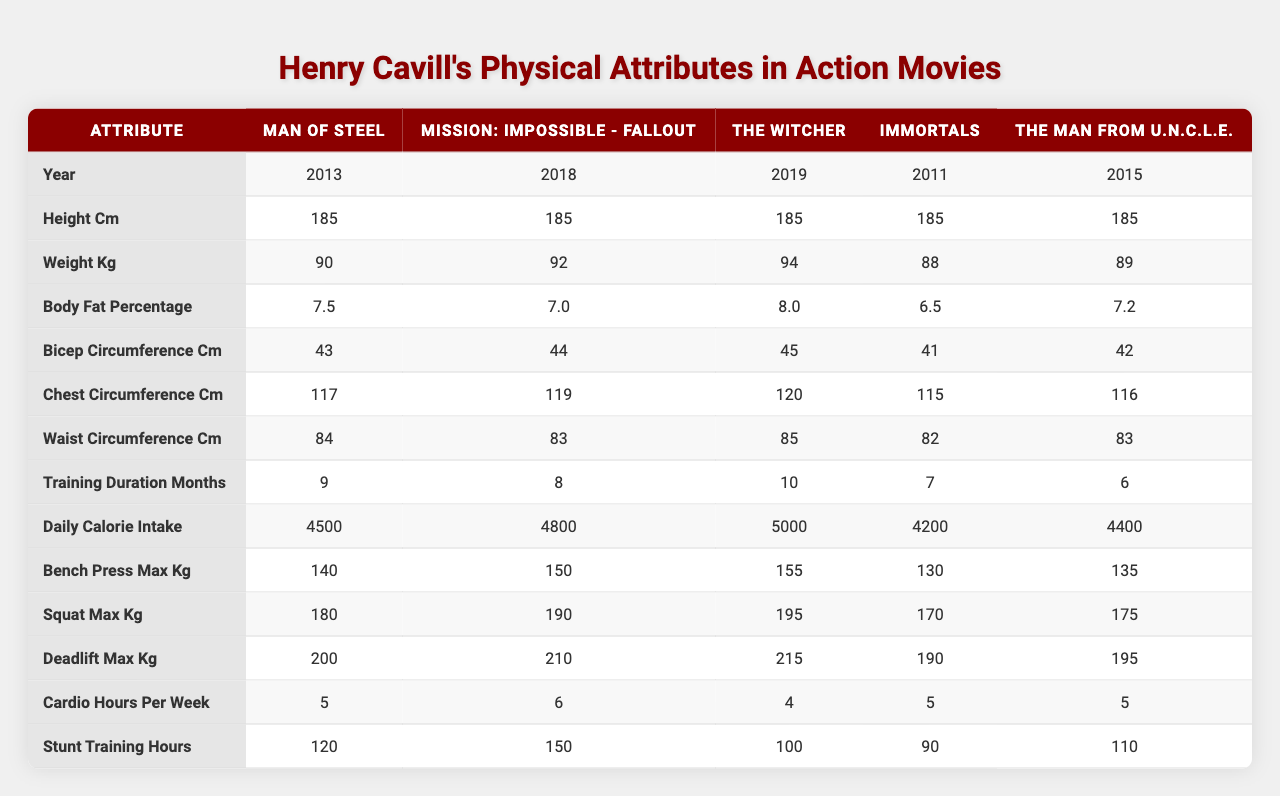What is the height of Henry Cavill in all these movies? The height is consistent across all listed movies, as seen in the table where each entry shows a height of 185 cm.
Answer: 185 cm What is the weight of Henry Cavill in "Man of Steel"? Referring to the entry for "Man of Steel" in the weight column, it shows 90 kg.
Answer: 90 kg Which movie had the highest body fat percentage for Henry Cavill? By comparing the body fat percentages across the movies listed, "The Witcher" has the highest percentage at 8.0%.
Answer: The Witcher Calculate the average weight of Henry Cavill across all movies listed. Adding the weights: 90 + 92 + 94 + 88 + 89 = 453 kg. There are 5 movies, so dividing 453 by 5 gives an average of 90.6 kg.
Answer: 90.6 kg True or False: Henry Cavill's maximum deadlift weight was the same in "Immortals" and "The Man from U.N.C.L.E." The table shows the deadlift maximum for "Immortals" is 190 kg and for "The Man from U.N.C.L.E." it is 195 kg. Since these are not equal, the statement is false.
Answer: False Which movie required the least training duration in months? By reviewing the training duration column, "The Man from U.N.C.L.E." has the least training duration at 6 months.
Answer: The Man from U.N.C.L.E What is the difference in bench press max weight between "Mission: Impossible - Fallout" and "Immortals"? The bench press max for "Mission: Impossible - Fallout" is 150 kg and for "Immortals" it is 130 kg. The difference is 150 - 130 = 20 kg.
Answer: 20 kg Which movie had the highest calorie intake, and what was that value? From the daily calorie intake column, "The Witcher" shows the highest at 5000 calories.
Answer: 5000 calories If we consider the cardio hours per week, which movies had the same value? Looking at the cardio hours, "Man of Steel," "Immortals," and "The Man from U.N.C.L.E." all have 5 hours.
Answer: Man of Steel, Immortals, The Man from U.N.C.L.E What was the maximum squat weight for Henry Cavill in "The Witcher"? The squat maximum weight listed for "The Witcher" in the table is 195 kg.
Answer: 195 kg 